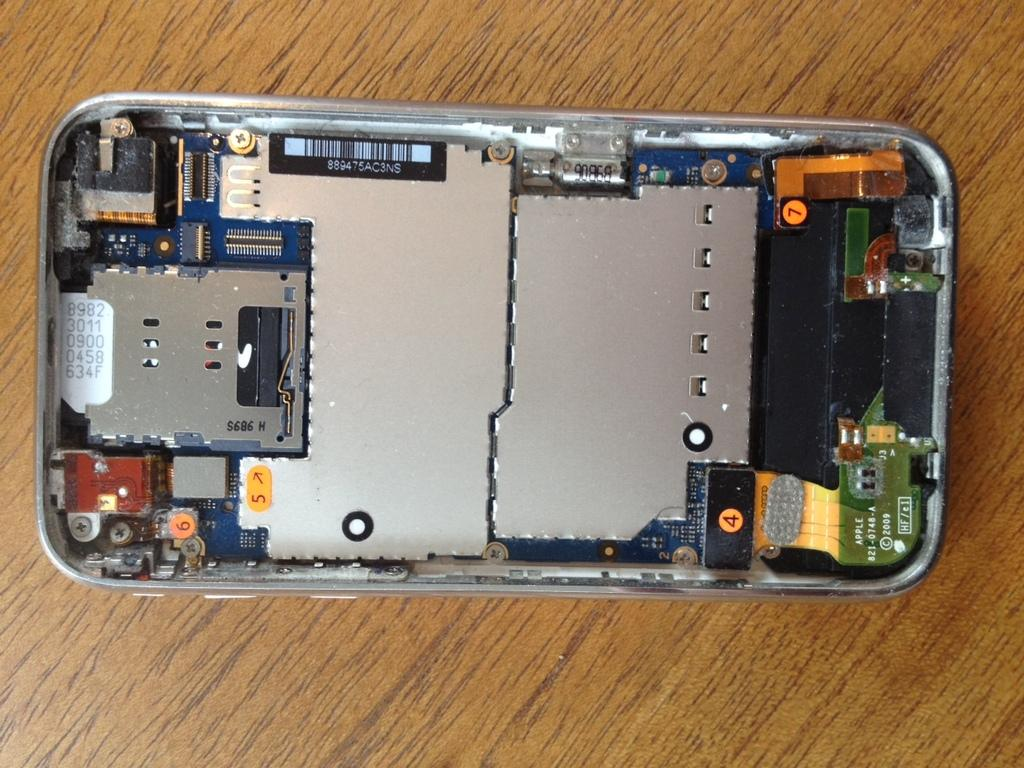<image>
Present a compact description of the photo's key features. The back of the phone is removed to show the parts, 4, 5 and 7. 